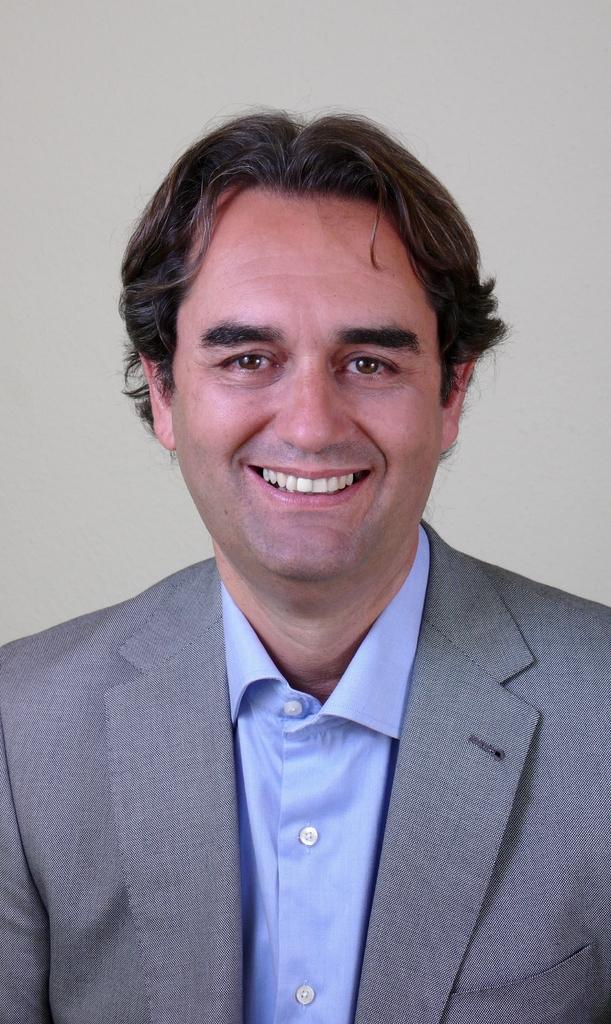Who is present in the image? There is a man in the image. What is the man's facial expression? The man has a smiling face. What color is the background of the image? The background of the image is white. What type of prose is the man reading in the image? There is no prose present in the image; the man is simply smiling with a white background. Is there a sofa visible in the image? No, there is no sofa present in the image. 